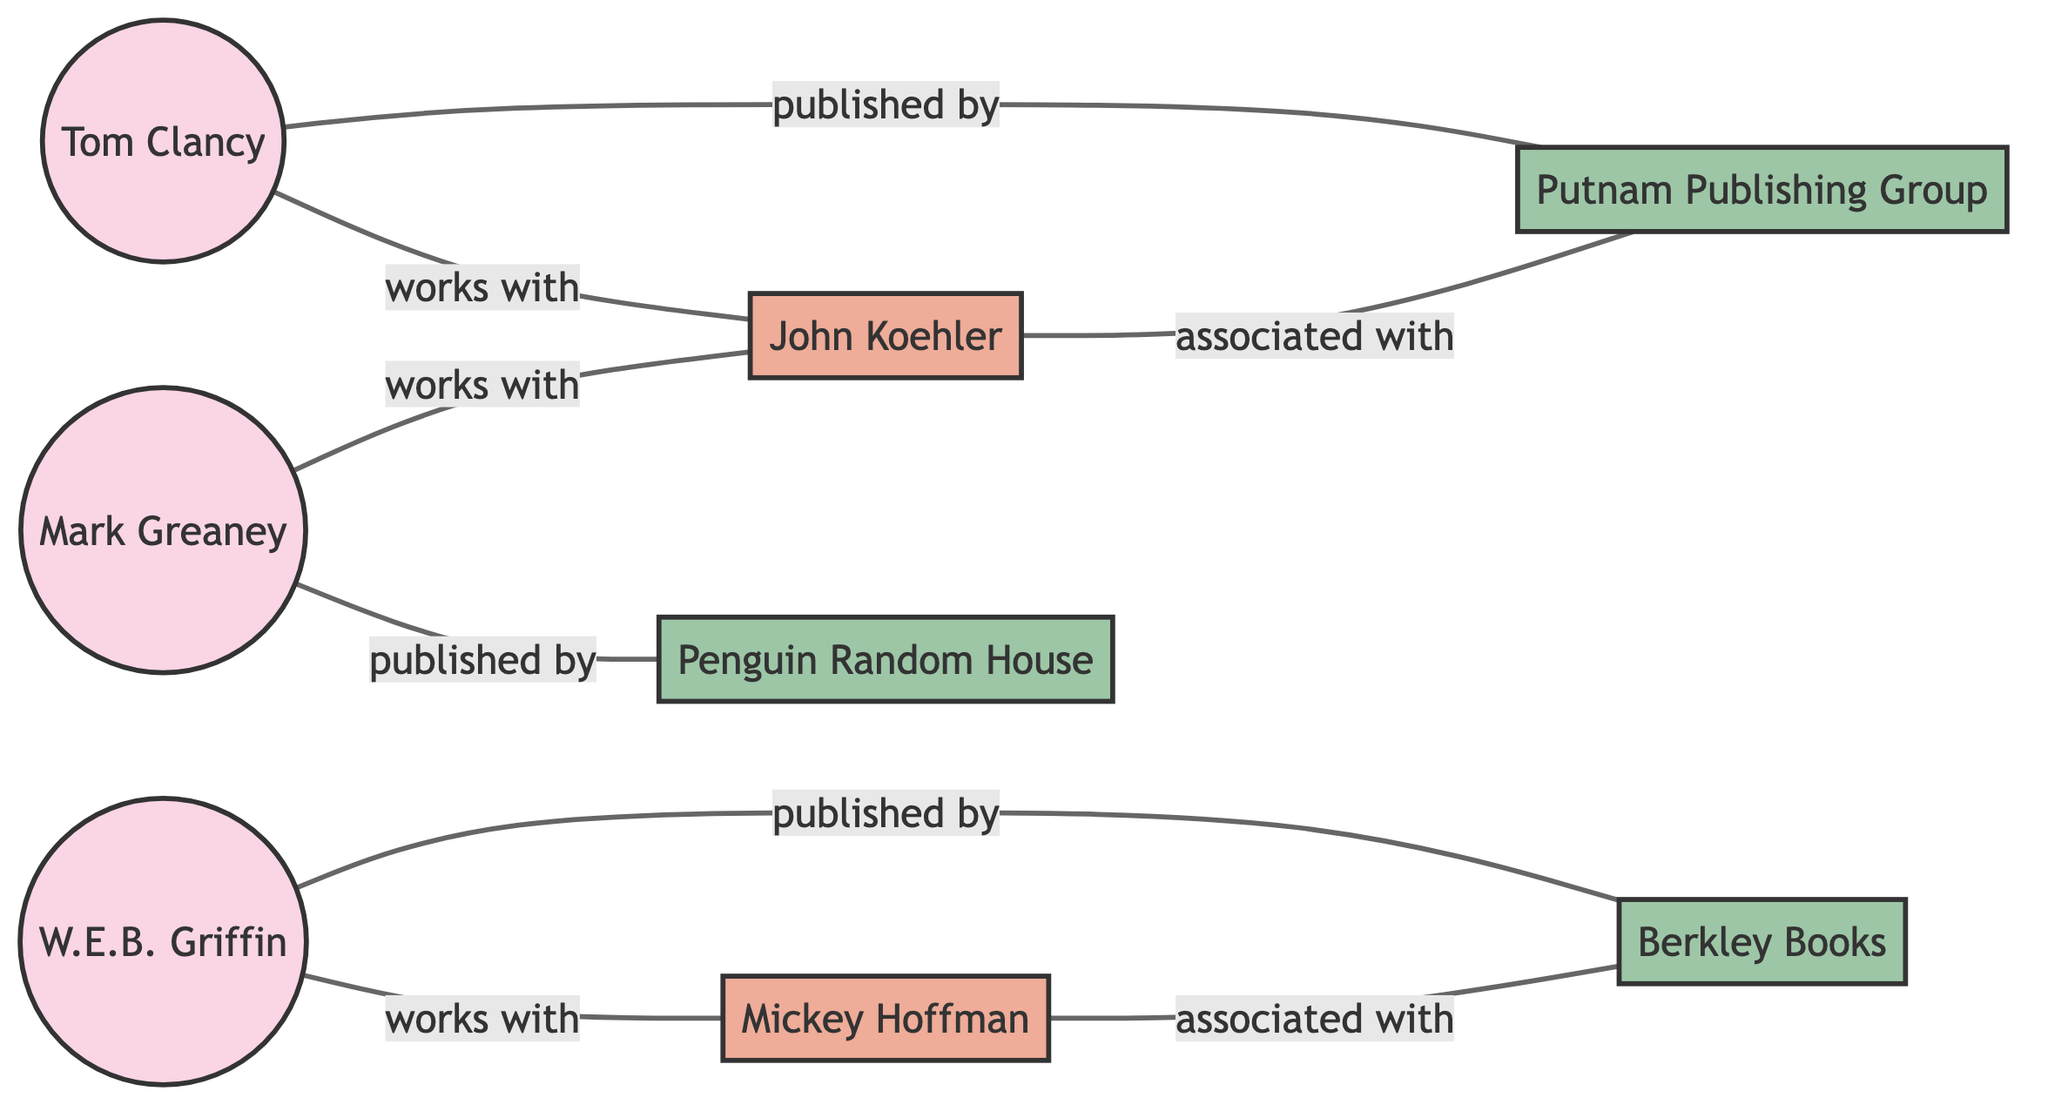What are the names of the authors in the diagram? The diagram includes three authors: Tom Clancy, W.E.B. Griffin, and Mark Greaney.
Answer: Tom Clancy, W.E.B. Griffin, Mark Greaney Which editor is associated with the most authors? The diagram shows that John Koehler is the editor who works with two authors: Tom Clancy and Mark Greaney, while Mickey Hoffman only works with W.E.B. Griffin. Thus, John Koehler is associated with more authors.
Answer: John Koehler How many publishers are represented in the diagram? There are three publishers shown in the diagram: Berkley Books, Penguin Random House, and Putnam Publishing Group.
Answer: 3 Which author is published by Putnam Publishing Group? Mark Greaney is identified in the diagram as the author published by Putnam Publishing Group.
Answer: Mark Greaney What is the relationship between Tom Clancy and Putnam Publishing Group? In the diagram, there is a direct connection indicating that Tom Clancy is not published by Putnam Publishing Group, as he is linked to publisher Berkley Books.
Answer: None How many edges connect authors to their respective editors? Counting the connections, there are three edges showing authors working with editors. Tom Clancy connects to John Koehler, W.E.B. Griffin connects to Mickey Hoffman, and Mark Greaney connects to John Koehler.
Answer: 3 Which publisher is associated with Mickey Hoffman? The diagram specifies that Mickey Hoffman is associated with Berkley Books as an editor.
Answer: Berkley Books Who is the editor associated with Putnam Publishing Group? The diagram shows that there is no direct connection between Putnam Publishing Group and any editor, but only Mark Greaney is published by them, which suggests that he works with an unspecified editor.
Answer: None 